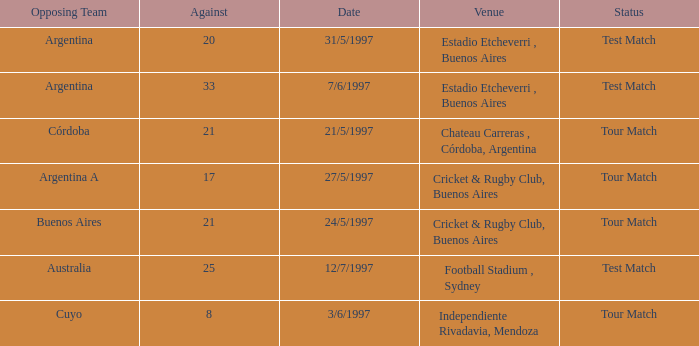Which venue has an against value larger than 21 and had Argentina as an opposing team. Estadio Etcheverri , Buenos Aires. Parse the table in full. {'header': ['Opposing Team', 'Against', 'Date', 'Venue', 'Status'], 'rows': [['Argentina', '20', '31/5/1997', 'Estadio Etcheverri , Buenos Aires', 'Test Match'], ['Argentina', '33', '7/6/1997', 'Estadio Etcheverri , Buenos Aires', 'Test Match'], ['Córdoba', '21', '21/5/1997', 'Chateau Carreras , Córdoba, Argentina', 'Tour Match'], ['Argentina A', '17', '27/5/1997', 'Cricket & Rugby Club, Buenos Aires', 'Tour Match'], ['Buenos Aires', '21', '24/5/1997', 'Cricket & Rugby Club, Buenos Aires', 'Tour Match'], ['Australia', '25', '12/7/1997', 'Football Stadium , Sydney', 'Test Match'], ['Cuyo', '8', '3/6/1997', 'Independiente Rivadavia, Mendoza', 'Tour Match']]} 